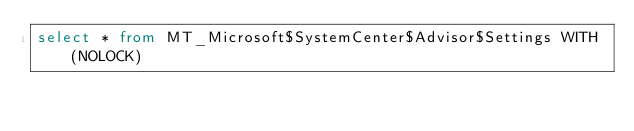Convert code to text. <code><loc_0><loc_0><loc_500><loc_500><_SQL_>select * from MT_Microsoft$SystemCenter$Advisor$Settings WITH (NOLOCK)</code> 